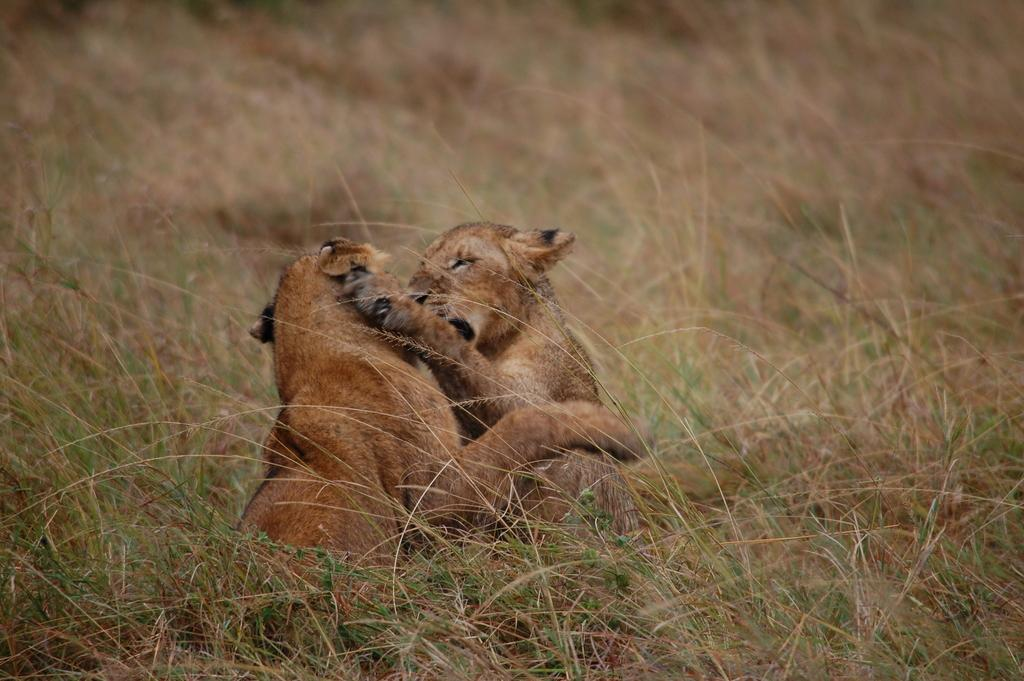What is located in the center of the image? There are animals in the center of the image. What can be seen at the bottom of the image? The ground is visible at the bottom of the image. What type of vegetation covers the ground in the image? The ground is covered with grass. What type of base can be seen supporting the animals in the image? There is no base visible in the image; the animals are likely standing on the grass-covered ground. 